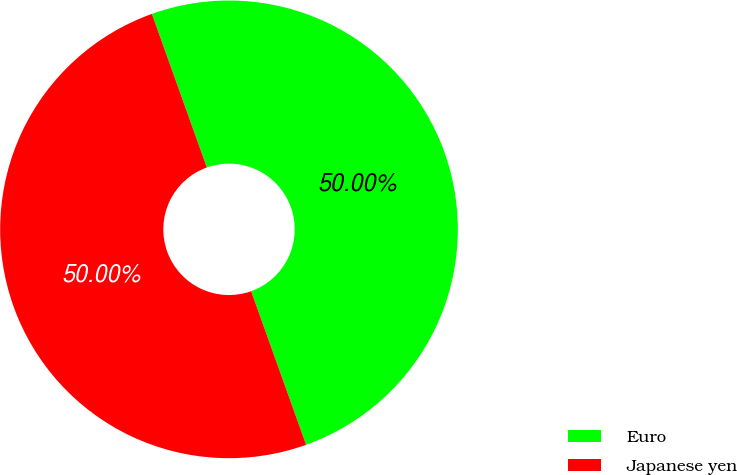Convert chart. <chart><loc_0><loc_0><loc_500><loc_500><pie_chart><fcel>Euro<fcel>Japanese yen<nl><fcel>50.0%<fcel>50.0%<nl></chart> 